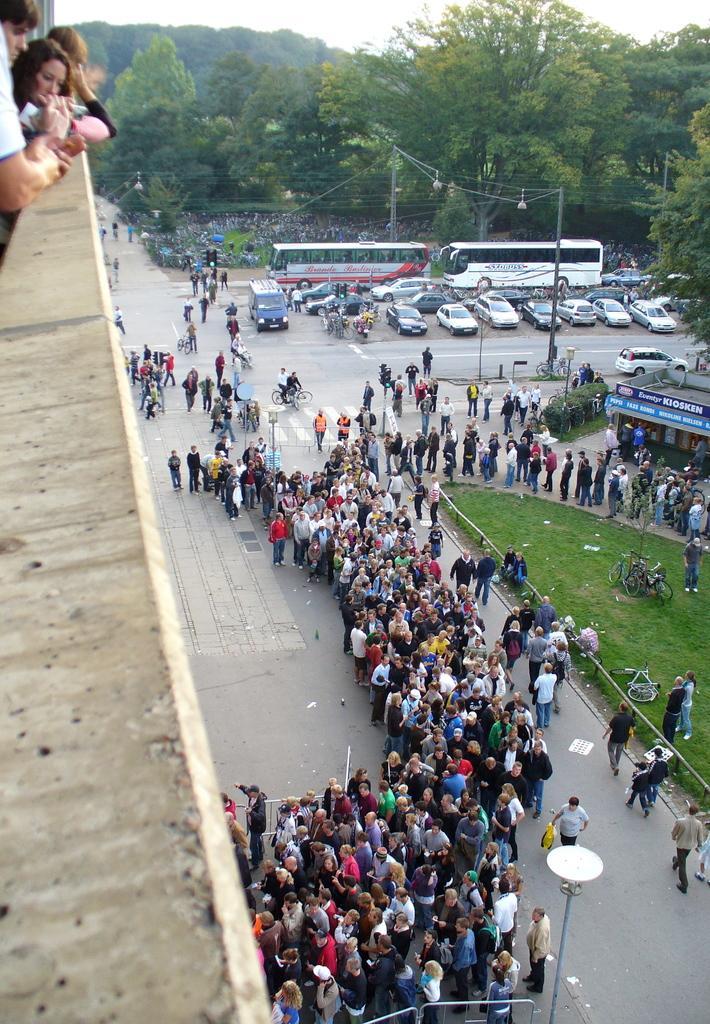Could you give a brief overview of what you see in this image? In the foreground of this image, it seems like a wall and few persons standing on the top. On the bottom, there is the crowd standing on the road, bicycles on the grass, a building, vehicles on the road, trees and the sky on the top. 